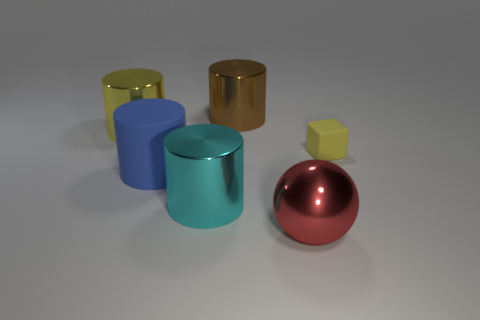Are there any other things that have the same shape as the tiny thing?
Offer a very short reply. No. Is the brown shiny object the same shape as the big cyan shiny object?
Your response must be concise. Yes. What number of large things are matte cubes or brown metal objects?
Ensure brevity in your answer.  1. What is the color of the small rubber object?
Provide a short and direct response. Yellow. There is a yellow object that is behind the yellow thing that is to the right of the big brown cylinder; what is its shape?
Offer a very short reply. Cylinder. Is there a large brown cylinder that has the same material as the big red ball?
Your answer should be compact. Yes. Is the size of the yellow thing on the left side of the yellow matte block the same as the large red sphere?
Provide a short and direct response. Yes. What number of cyan things are matte cylinders or large metallic things?
Your answer should be very brief. 1. There is a yellow thing in front of the large yellow object; what material is it?
Keep it short and to the point. Rubber. There is a yellow object that is to the left of the brown thing; how many cubes are on the right side of it?
Your answer should be compact. 1. 